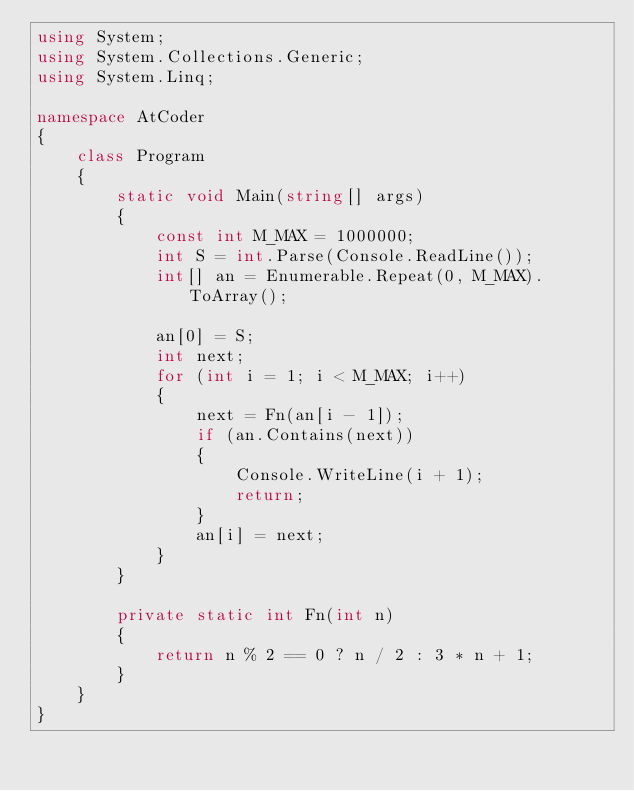Convert code to text. <code><loc_0><loc_0><loc_500><loc_500><_C#_>using System;
using System.Collections.Generic;
using System.Linq;

namespace AtCoder
{
    class Program
    {
        static void Main(string[] args)
        {
            const int M_MAX = 1000000;
            int S = int.Parse(Console.ReadLine());
            int[] an = Enumerable.Repeat(0, M_MAX).ToArray();

            an[0] = S;
            int next;
            for (int i = 1; i < M_MAX; i++)
            {
                next = Fn(an[i - 1]);
                if (an.Contains(next))
                {
                    Console.WriteLine(i + 1);
                    return;
                }
                an[i] = next;
            }
        }

        private static int Fn(int n)
        {
            return n % 2 == 0 ? n / 2 : 3 * n + 1;
        }
    }
}

</code> 